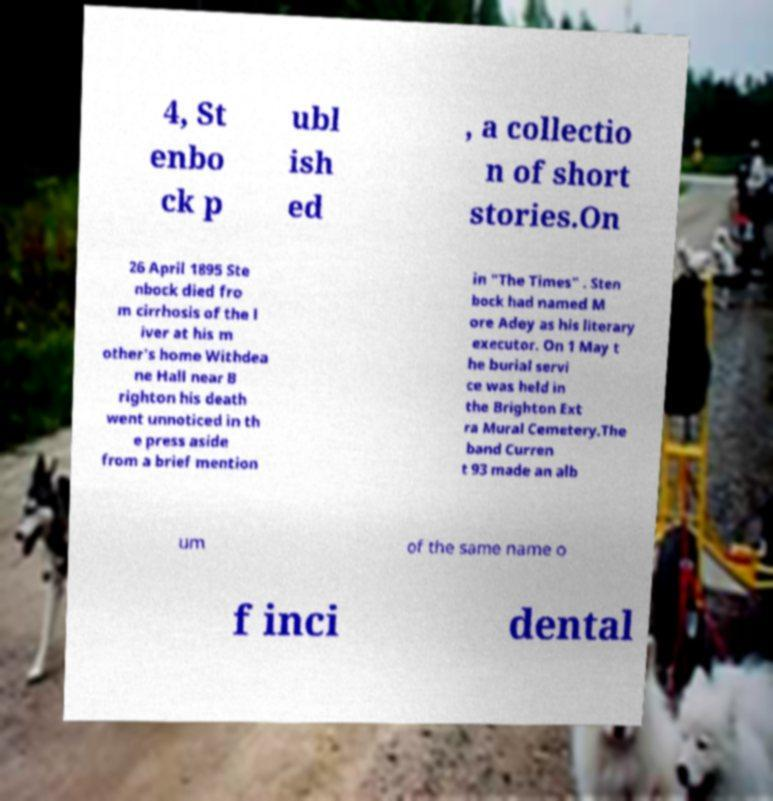Can you accurately transcribe the text from the provided image for me? 4, St enbo ck p ubl ish ed , a collectio n of short stories.On 26 April 1895 Ste nbock died fro m cirrhosis of the l iver at his m other's home Withdea ne Hall near B righton his death went unnoticed in th e press aside from a brief mention in "The Times" . Sten bock had named M ore Adey as his literary executor. On 1 May t he burial servi ce was held in the Brighton Ext ra Mural Cemetery.The band Curren t 93 made an alb um of the same name o f inci dental 